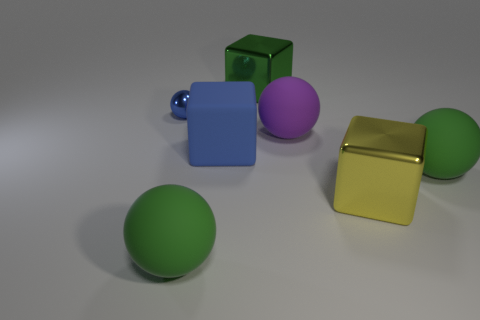What material is the tiny thing that is the same color as the big rubber cube?
Your answer should be compact. Metal. What material is the big yellow thing that is the same shape as the big green metallic thing?
Ensure brevity in your answer.  Metal. Is the size of the green sphere left of the green shiny object the same as the small blue sphere?
Make the answer very short. No. What number of shiny objects are either blue blocks or small purple blocks?
Your response must be concise. 0. The large green thing that is both in front of the tiny blue metal sphere and behind the big yellow shiny cube is made of what material?
Keep it short and to the point. Rubber. Does the blue cube have the same material as the yellow object?
Ensure brevity in your answer.  No. What is the size of the thing that is both on the left side of the big blue thing and behind the big purple matte sphere?
Provide a succinct answer. Small. The purple object is what shape?
Your response must be concise. Sphere. How many objects are either blue balls or green matte things to the right of the green shiny thing?
Your response must be concise. 2. There is a small object behind the purple thing; does it have the same color as the big rubber cube?
Keep it short and to the point. Yes. 